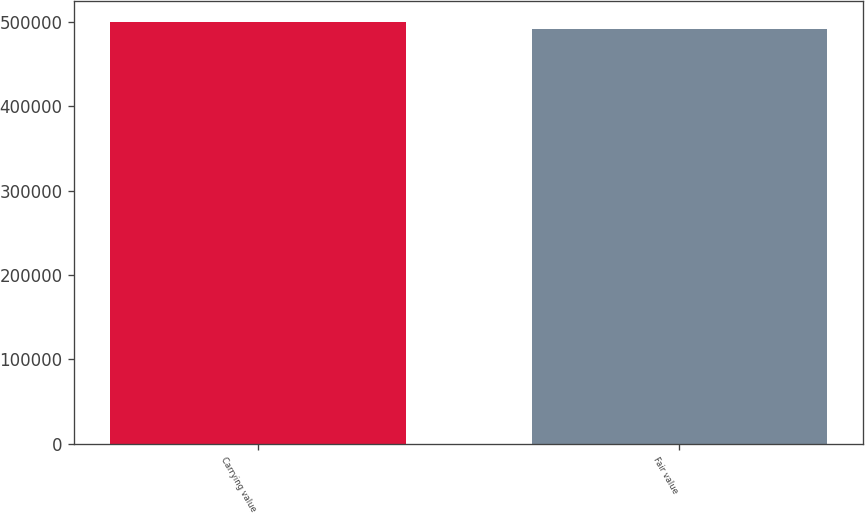Convert chart. <chart><loc_0><loc_0><loc_500><loc_500><bar_chart><fcel>Carrying value<fcel>Fair value<nl><fcel>500000<fcel>492163<nl></chart> 